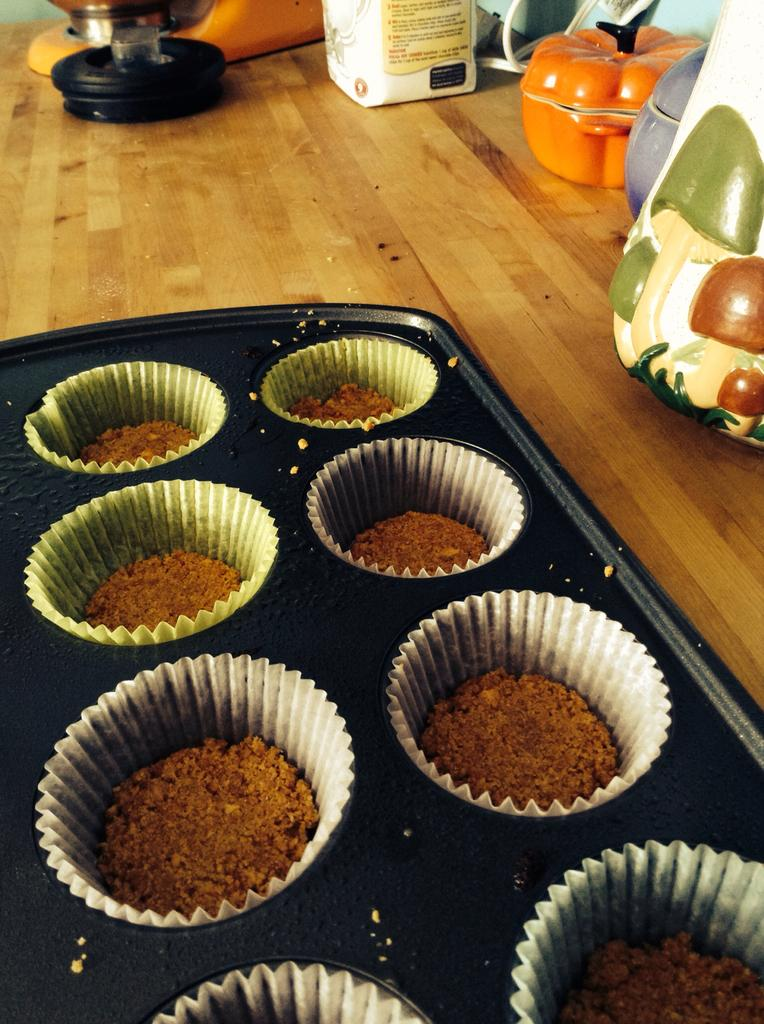What type of food can be seen in the image? There are muffins in the image. What is the setting of the image? The image features a train, as indicated by the presence of papers on the train. What type of containers are visible in the image? There are boxes in the image. What is used to cover or seal something in the image? There is a lid in the image. What is present on the table in the image? There are objects on the table in the image. What time does the clock on the table show in the image? There is no clock present in the image, so it is not possible to determine the time. 